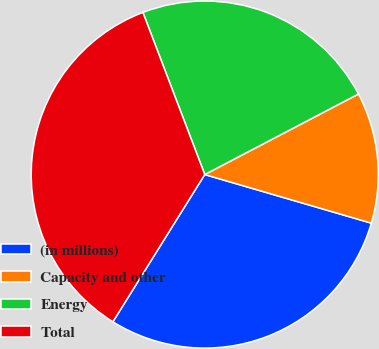<chart> <loc_0><loc_0><loc_500><loc_500><pie_chart><fcel>(in millions)<fcel>Capacity and other<fcel>Energy<fcel>Total<nl><fcel>29.36%<fcel>12.2%<fcel>23.12%<fcel>35.32%<nl></chart> 